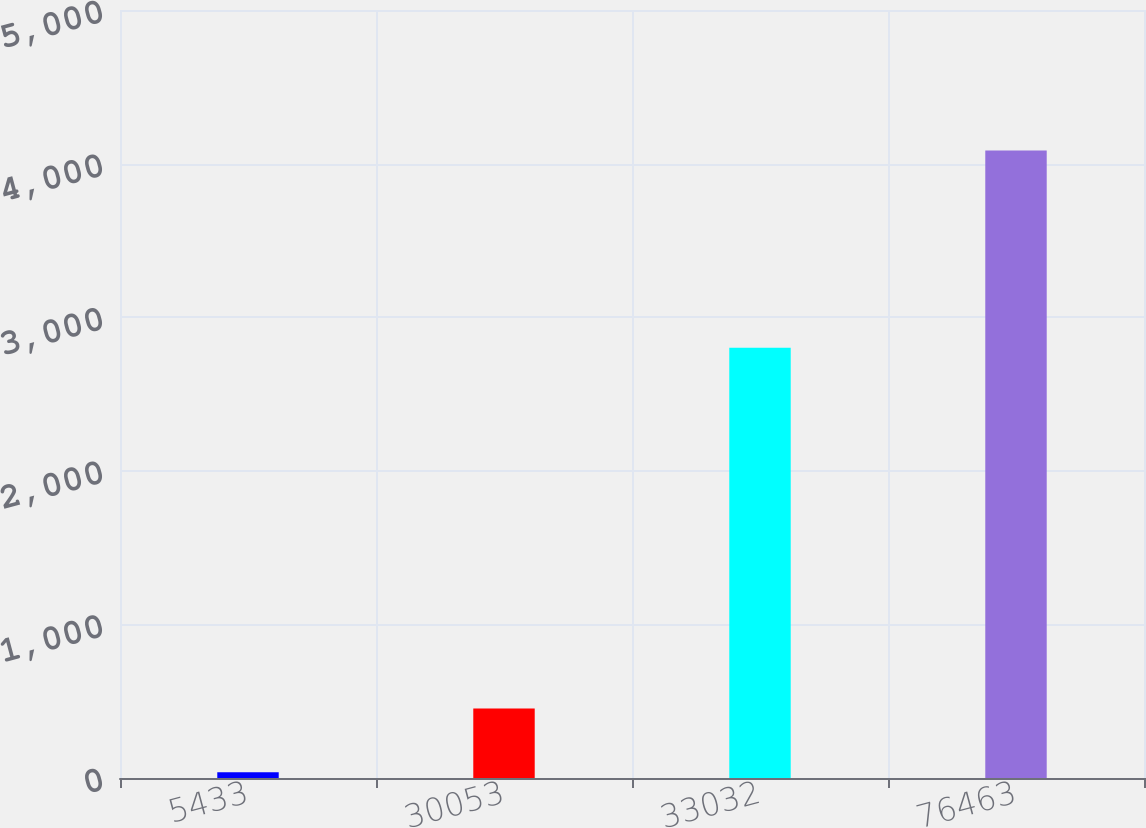<chart> <loc_0><loc_0><loc_500><loc_500><bar_chart><fcel>5433<fcel>30053<fcel>33032<fcel>76463<nl><fcel>37.3<fcel>452.4<fcel>2800.9<fcel>4085.1<nl></chart> 